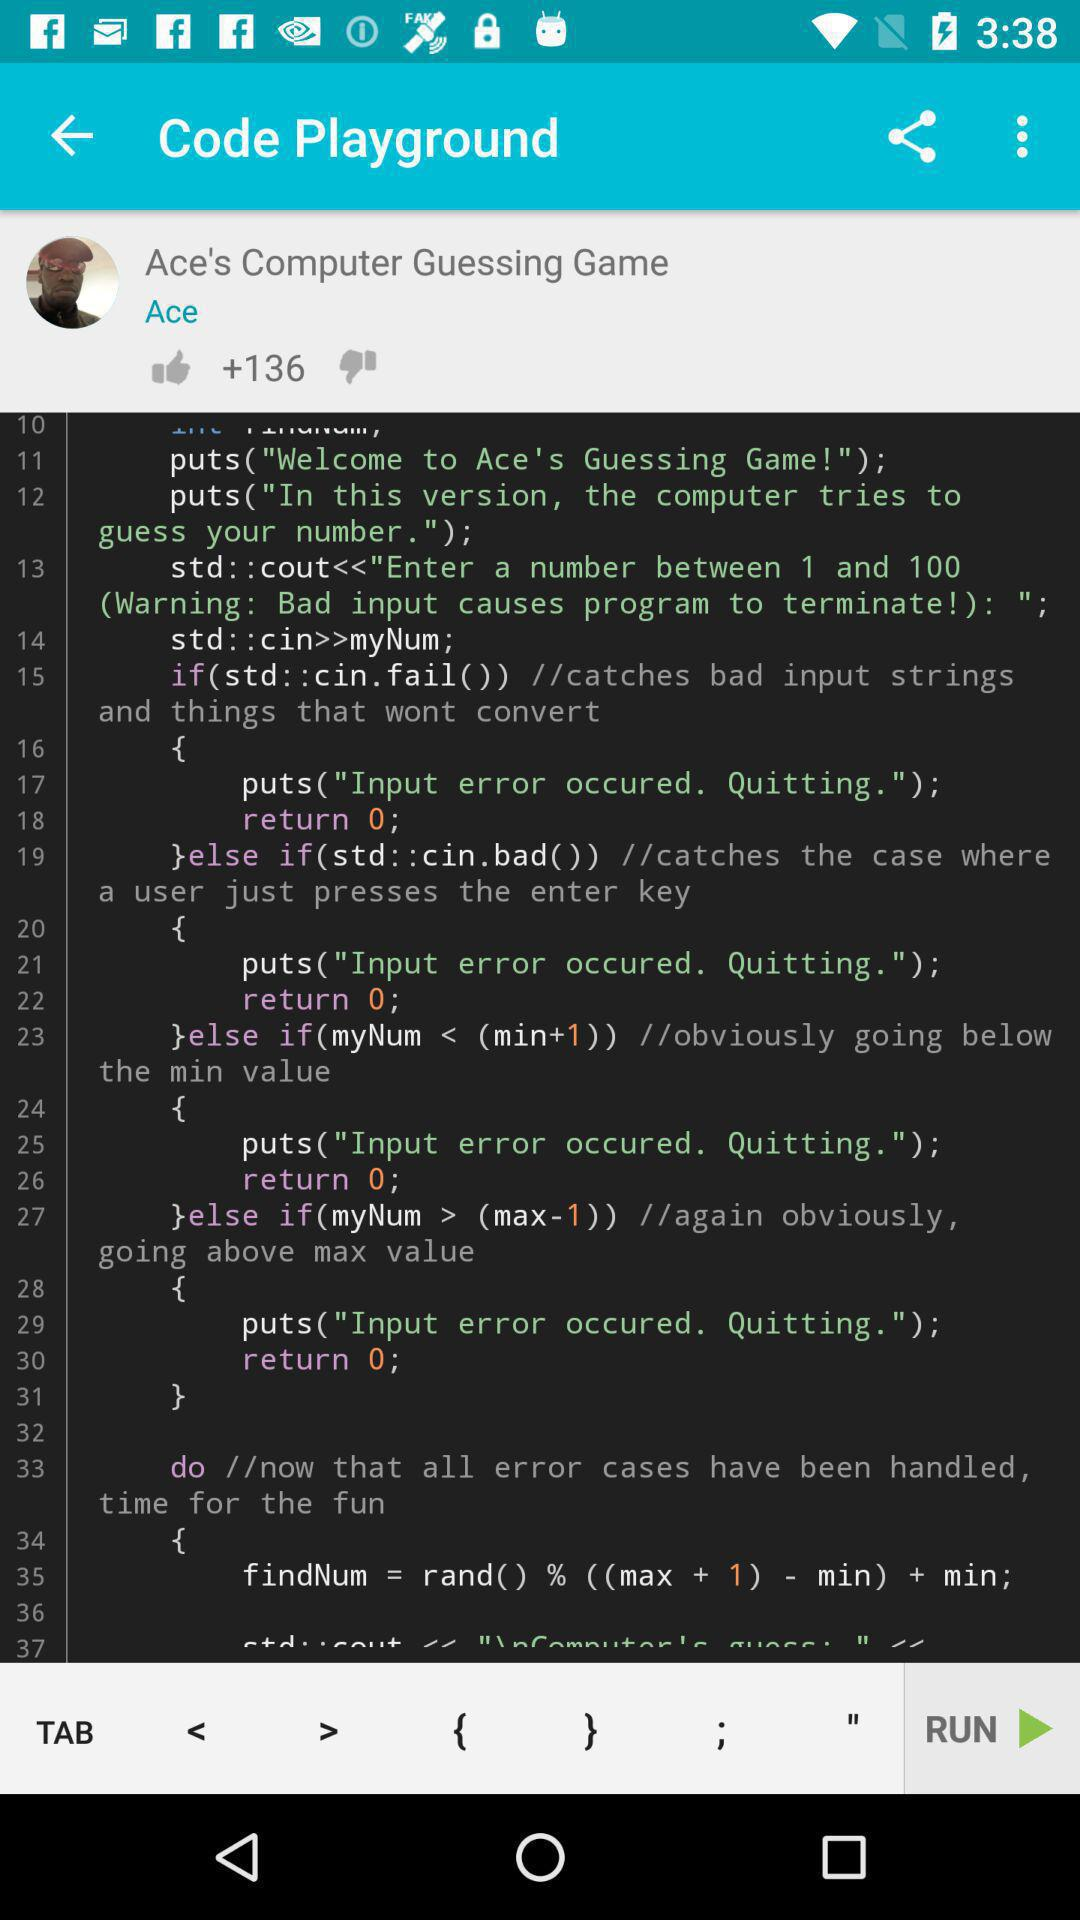When was "Ace's Computer Guessing Game" uploaded?
When the provided information is insufficient, respond with <no answer>. <no answer> 